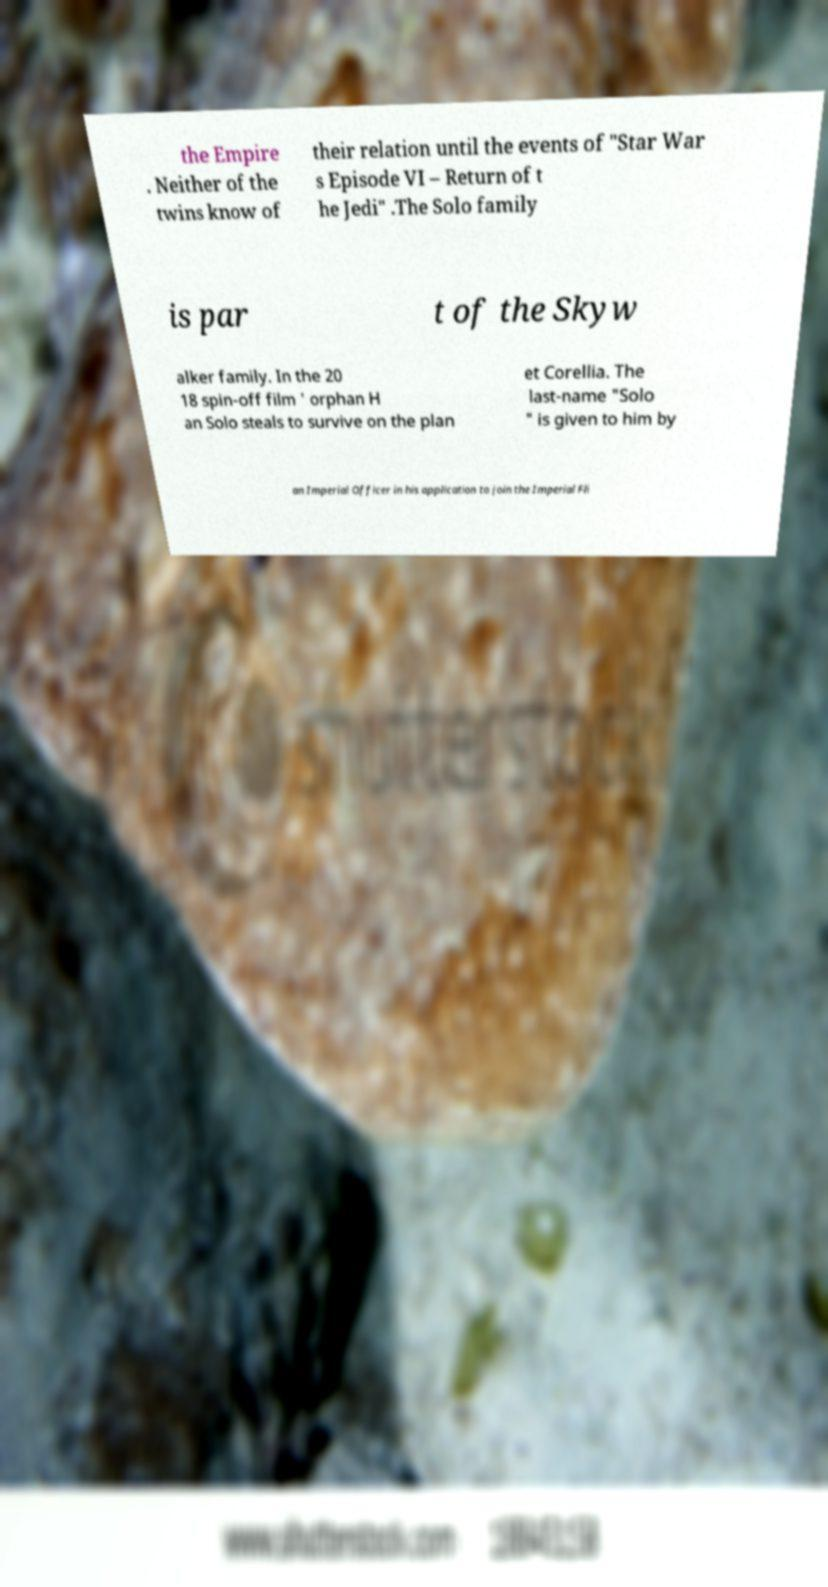Could you assist in decoding the text presented in this image and type it out clearly? the Empire . Neither of the twins know of their relation until the events of "Star War s Episode VI – Return of t he Jedi" .The Solo family is par t of the Skyw alker family. In the 20 18 spin-off film ' orphan H an Solo steals to survive on the plan et Corellia. The last-name "Solo " is given to him by an Imperial Officer in his application to join the Imperial Fli 